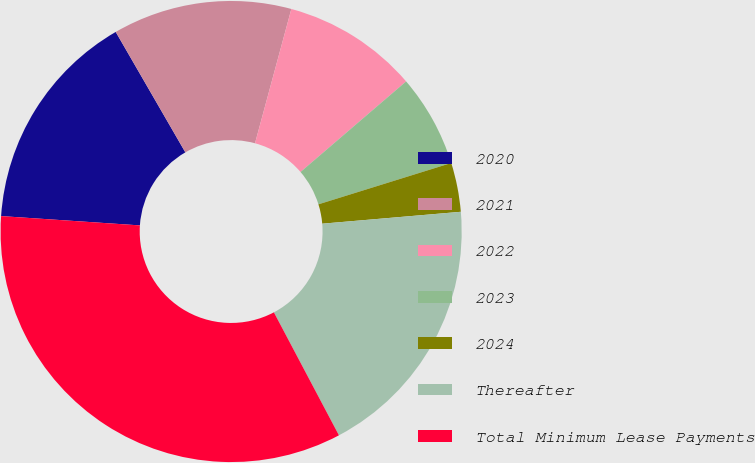<chart> <loc_0><loc_0><loc_500><loc_500><pie_chart><fcel>2020<fcel>2021<fcel>2022<fcel>2023<fcel>2024<fcel>Thereafter<fcel>Total Minimum Lease Payments<nl><fcel>15.59%<fcel>12.55%<fcel>9.51%<fcel>6.48%<fcel>3.44%<fcel>18.62%<fcel>33.81%<nl></chart> 